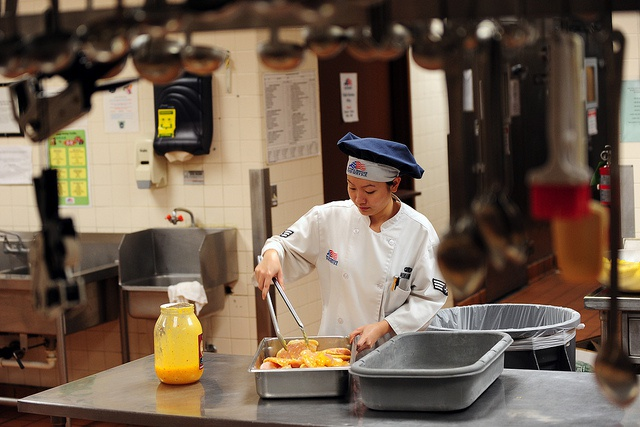Describe the objects in this image and their specific colors. I can see dining table in black, darkgray, gray, and tan tones, people in black, lightgray, tan, and darkgray tones, sink in black, gray, and maroon tones, bottle in black, gold, orange, and tan tones, and sink in black, gray, and maroon tones in this image. 